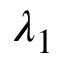Convert formula to latex. <formula><loc_0><loc_0><loc_500><loc_500>\lambda _ { 1 }</formula> 